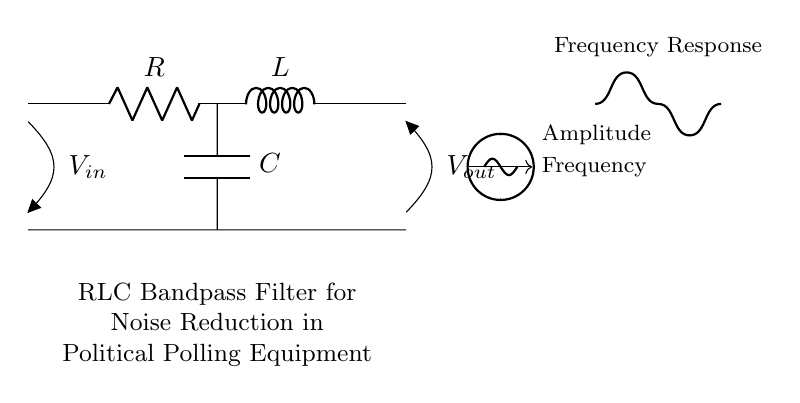What are the components in this circuit? The diagram shows three components: a resistor, an inductor, and a capacitor, which are connected in series to create an RLC bandpass filter.
Answer: Resistor, Inductor, Capacitor What is the configuration of the components? The resistor is connected in series with the inductor, and the capacitor is connected in parallel with the resistor, forming an RLC circuit to filter specific frequencies.
Answer: Series with parallel capacitor What is the purpose of this circuit? This RLC bandpass filter is designed to reduce noise in political polling equipment by allowing certain frequency signals to pass while attenuating others.
Answer: Noise reduction What is the expected output voltage relationship to input voltage? The output voltage is determined by the resonance frequency where maximum signal is passed through the circuit, compared to the input voltage.
Answer: Vout is related to Vin by resonance What happens to frequencies outside the passband? Frequencies outside the designed passband will be attenuated significantly, meaning they will have reduced amplitudes at the output compared to the input.
Answer: Attenuation of outside frequencies At what frequency does this circuit resonate? The resonant frequency is dependent on the values of the resistor, inductor, and capacitor, calculated using the formula that defines RLC circuits.
Answer: Resonant frequency formula dependent What type of filter is this circuit considered? This configuration, with both inductor and capacitor allowing certain frequencies through, classifies it as a bandpass filter specific to the RLC design.
Answer: Bandpass filter 